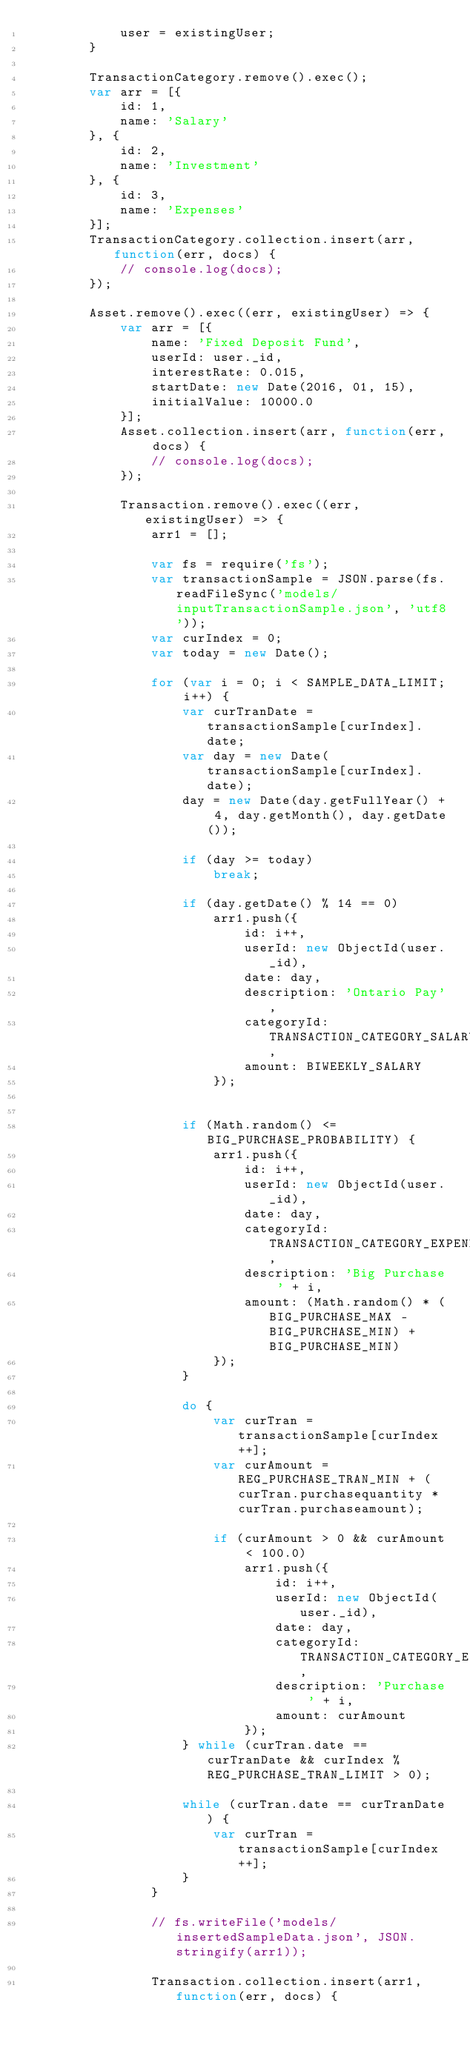Convert code to text. <code><loc_0><loc_0><loc_500><loc_500><_JavaScript_>			user = existingUser;
		}

		TransactionCategory.remove().exec();
		var arr = [{
			id: 1,
			name: 'Salary'
		}, {
			id: 2,
			name: 'Investment'
		}, {
			id: 3,
			name: 'Expenses'
		}];
		TransactionCategory.collection.insert(arr, function(err, docs) {
			// console.log(docs);
		});

		Asset.remove().exec((err, existingUser) => {
			var arr = [{
				name: 'Fixed Deposit Fund',
				userId: user._id,
				interestRate: 0.015,
				startDate: new Date(2016, 01, 15),
				initialValue: 10000.0
			}];
			Asset.collection.insert(arr, function(err, docs) {
				// console.log(docs);
			});

			Transaction.remove().exec((err, existingUser) => {
				arr1 = [];

				var fs = require('fs');
				var transactionSample = JSON.parse(fs.readFileSync('models/inputTransactionSample.json', 'utf8'));
				var curIndex = 0;
				var today = new Date();

				for (var i = 0; i < SAMPLE_DATA_LIMIT; i++) {
					var curTranDate = transactionSample[curIndex].date;
					var day = new Date(transactionSample[curIndex].date);
					day = new Date(day.getFullYear() + 4, day.getMonth(), day.getDate());

					if (day >= today)
						break;

					if (day.getDate() % 14 == 0)
						arr1.push({
							id: i++,
							userId: new ObjectId(user._id),
							date: day,
							description: 'Ontario Pay',
							categoryId: TRANSACTION_CATEGORY_SALARY,
							amount: BIWEEKLY_SALARY
						});


					if (Math.random() <= BIG_PURCHASE_PROBABILITY) {
						arr1.push({
							id: i++,
							userId: new ObjectId(user._id),
							date: day,
							categoryId: TRANSACTION_CATEGORY_EXPENDITURES,
							description: 'Big Purchase ' + i,
							amount: (Math.random() * (BIG_PURCHASE_MAX - BIG_PURCHASE_MIN) + BIG_PURCHASE_MIN)
						});
					}

					do {
						var curTran = transactionSample[curIndex++];
						var curAmount = REG_PURCHASE_TRAN_MIN + (curTran.purchasequantity * curTran.purchaseamount);

						if (curAmount > 0 && curAmount < 100.0)
							arr1.push({
								id: i++,
								userId: new ObjectId(user._id),
								date: day,
								categoryId: TRANSACTION_CATEGORY_EXPENDITURES,
								description: 'Purchase ' + i,
								amount: curAmount
							});
					} while (curTran.date == curTranDate && curIndex % REG_PURCHASE_TRAN_LIMIT > 0);

					while (curTran.date == curTranDate) {
						var curTran = transactionSample[curIndex++];
					}
				}

				// fs.writeFile('models/insertedSampleData.json', JSON.stringify(arr1));

				Transaction.collection.insert(arr1, function(err, docs) {</code> 